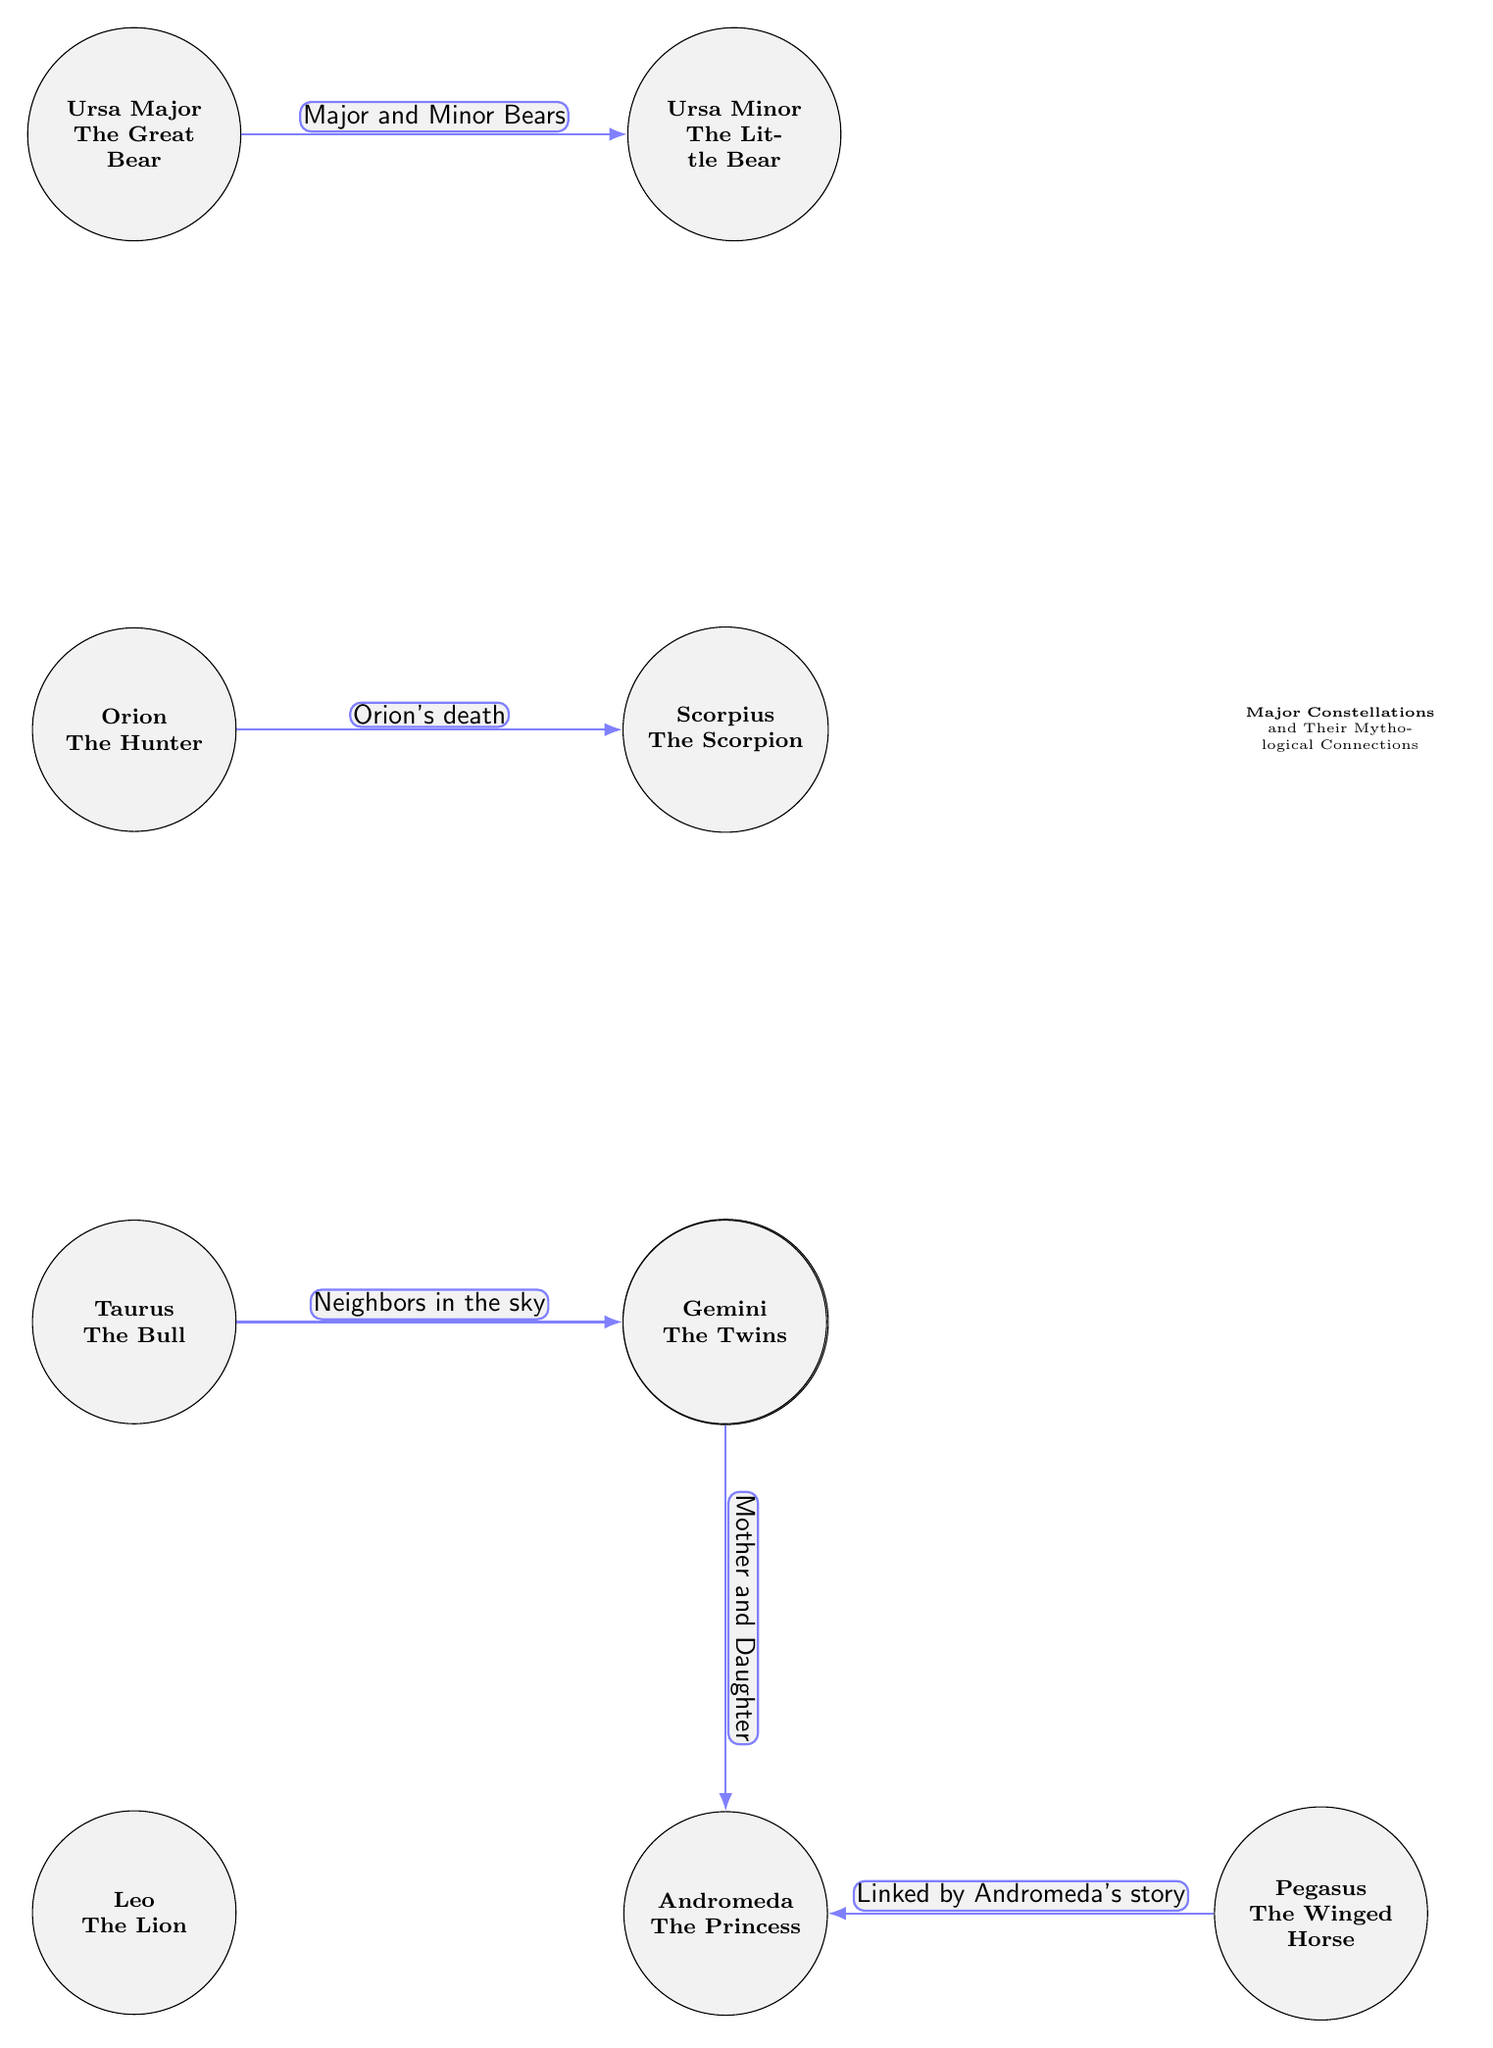What are the two bears in the diagram? The diagram points out Ursa Major and Ursa Minor, which are both depicted as constellations. They are directly connected, indicating their relationship.
Answer: Ursa Major, Ursa Minor How many constellations are represented in the diagram? Counting the nodes in the diagram, we see that there are a total of 10 constellations displayed.
Answer: 10 What is the mythological story connecting Orion and Scorpius? The diagram specifies that the connection between Orion and Scorpius is due to "Orion's death," indicating a mythological tale related to their relationship.
Answer: Orion's death Which constellation is linked to Andromeda's story? The diagram indicates that Pegasus is connected to Andromeda's story, establishing a mythological link between these two constellations.
Answer: Pegasus What do Taurus and Gemini represent in relation to each other? According to the diagram, Taurus and Gemini are described as "Neighbors in the sky," showing their proximity and connection in mythology.
Answer: Neighbors in the sky Which two constellations are referred to as mother and daughter? The connection labeled "Mother and Daughter" in the diagram points to Cassiopeia and Andromeda, indicating their familial relationship in the mythology.
Answer: Cassiopeia, Andromeda What connects Ursa Major and Ursa Minor? The connection line between Ursa Major and Ursa Minor specifies "Major and Minor Bears," which describes their relationship as two different forms of bears in the mythology.
Answer: Major and Minor Bears 